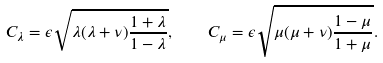Convert formula to latex. <formula><loc_0><loc_0><loc_500><loc_500>C _ { \lambda } = \epsilon \sqrt { \lambda ( \lambda + \nu ) \frac { 1 + \lambda } { 1 - \lambda } } , \quad C _ { \mu } = \epsilon \sqrt { \mu ( \mu + \nu ) \frac { 1 - \mu } { 1 + \mu } } .</formula> 